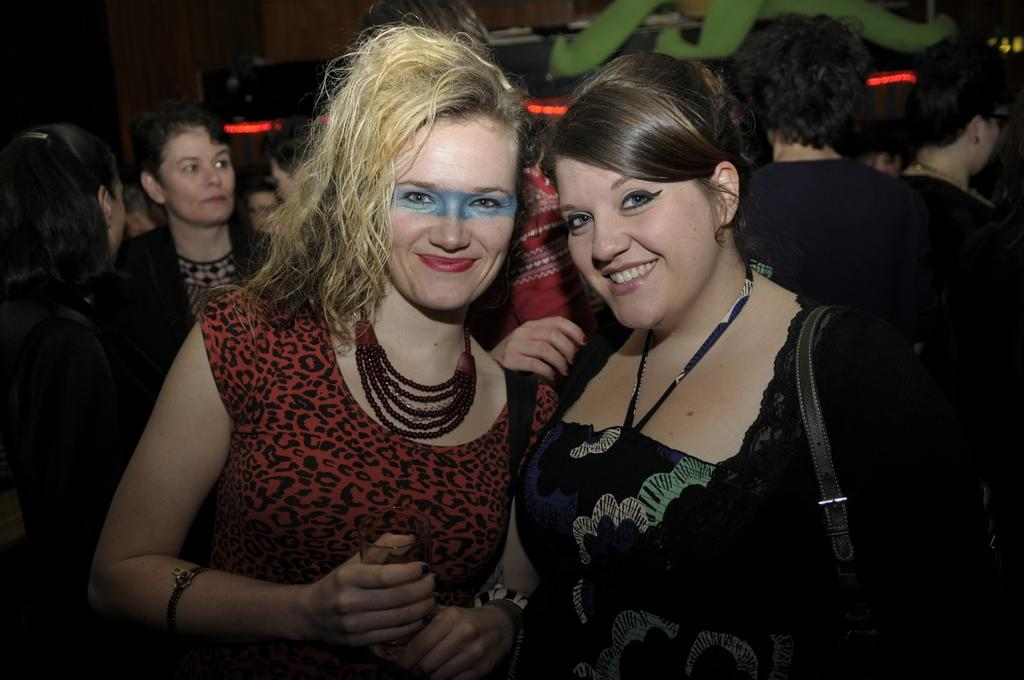What is the main subject of the image? The main subject of the image is a group of people. Can you describe the appearance of the people in the image? The people in the image are wearing clothes. Is there a specific person you can identify in the image? Yes, there is a person on the right side of the image. What is the person on the right side of the image wearing? The person on the right side is wearing a bag. What month is depicted in the image? There is no specific month depicted in the image; it is a group of people wearing clothes and one person wearing a bag. How many cobwebs can be seen in the image? There are no cobwebs present in the image. 